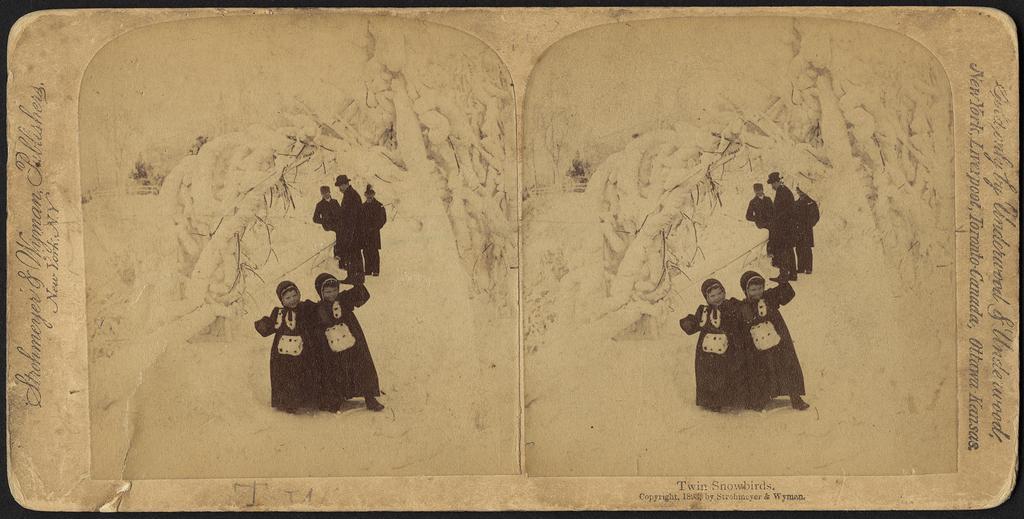In one or two sentences, can you explain what this image depicts? In this black and white image I can see a mirror reflection like paper with two similar sides with two kids and three people standing behind the kids. I can see some text on the right and left sides of the image along with the bottom. 